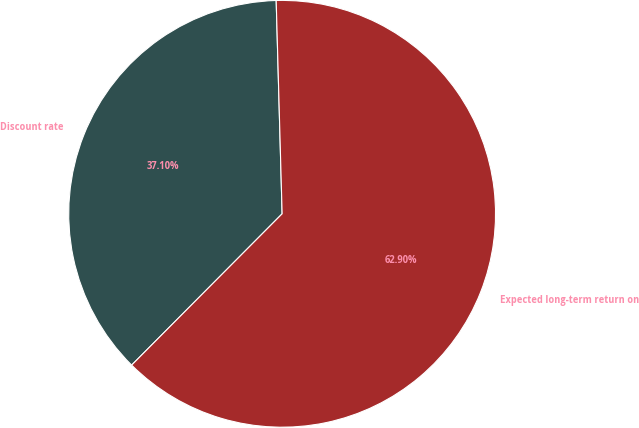Convert chart to OTSL. <chart><loc_0><loc_0><loc_500><loc_500><pie_chart><fcel>Discount rate<fcel>Expected long-term return on<nl><fcel>37.1%<fcel>62.9%<nl></chart> 